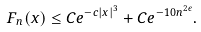Convert formula to latex. <formula><loc_0><loc_0><loc_500><loc_500>F _ { n } ( x ) \leq C e ^ { - c | x | ^ { 3 } } + C e ^ { - 1 0 n ^ { 2 \epsilon } } .</formula> 